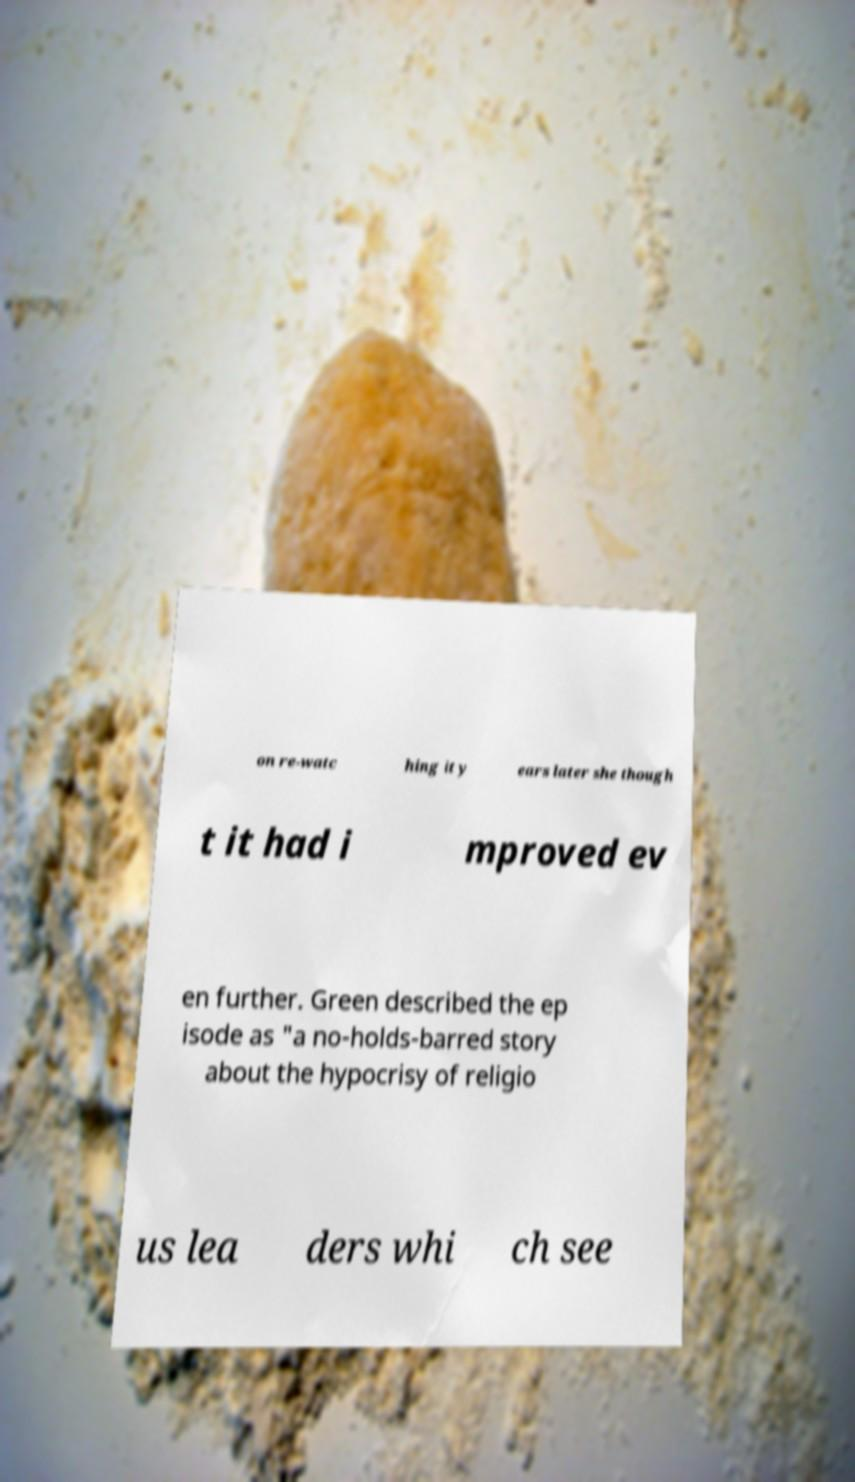Please identify and transcribe the text found in this image. on re-watc hing it y ears later she though t it had i mproved ev en further. Green described the ep isode as "a no-holds-barred story about the hypocrisy of religio us lea ders whi ch see 